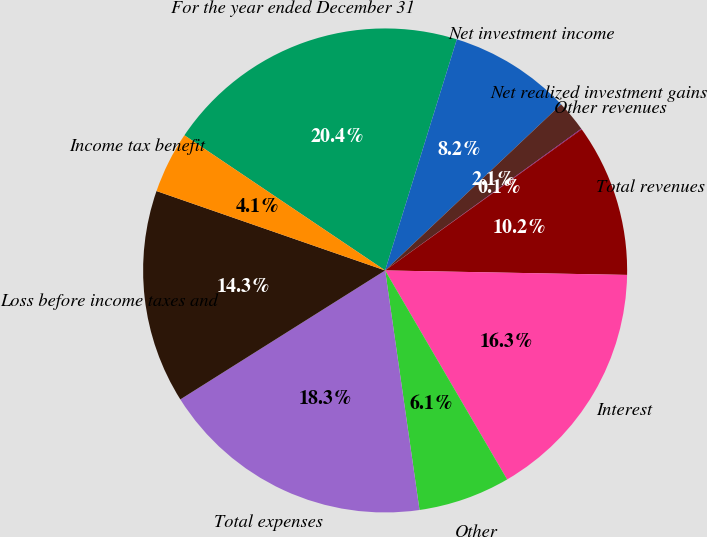Convert chart. <chart><loc_0><loc_0><loc_500><loc_500><pie_chart><fcel>For the year ended December 31<fcel>Net investment income<fcel>Net realized investment gains<fcel>Other revenues<fcel>Total revenues<fcel>Interest<fcel>Other<fcel>Total expenses<fcel>Loss before income taxes and<fcel>Income tax benefit<nl><fcel>20.35%<fcel>8.17%<fcel>2.08%<fcel>0.05%<fcel>10.2%<fcel>16.29%<fcel>6.14%<fcel>18.32%<fcel>14.26%<fcel>4.11%<nl></chart> 